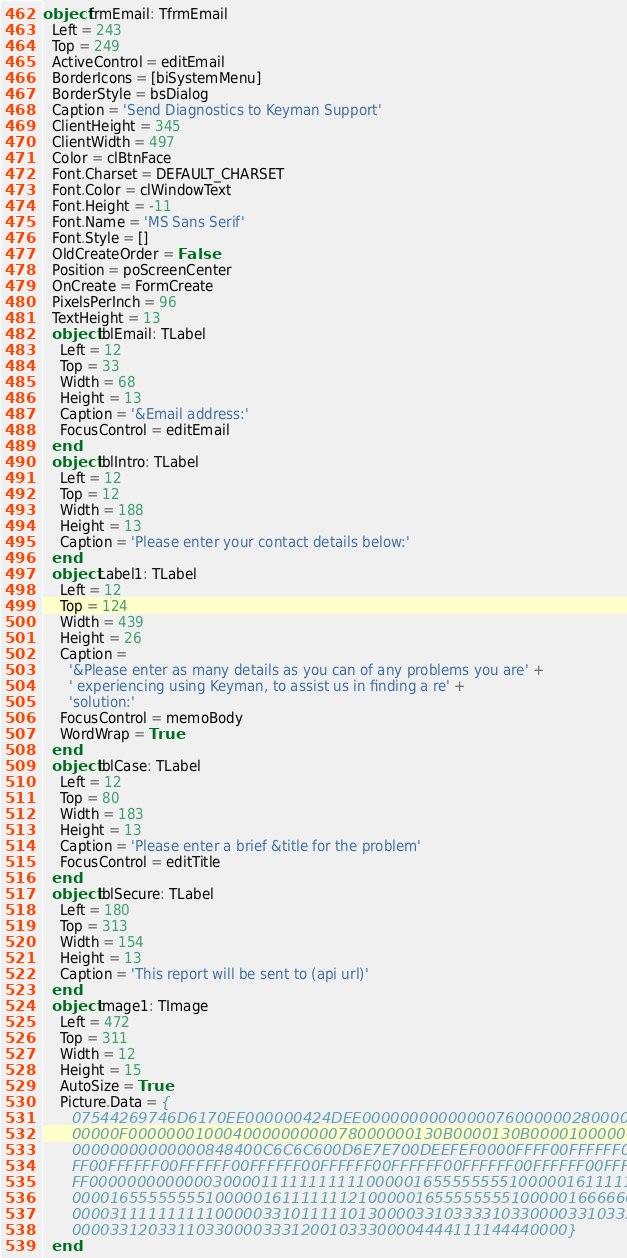Convert code to text. <code><loc_0><loc_0><loc_500><loc_500><_Pascal_>object frmEmail: TfrmEmail
  Left = 243
  Top = 249
  ActiveControl = editEmail
  BorderIcons = [biSystemMenu]
  BorderStyle = bsDialog
  Caption = 'Send Diagnostics to Keyman Support'
  ClientHeight = 345
  ClientWidth = 497
  Color = clBtnFace
  Font.Charset = DEFAULT_CHARSET
  Font.Color = clWindowText
  Font.Height = -11
  Font.Name = 'MS Sans Serif'
  Font.Style = []
  OldCreateOrder = False
  Position = poScreenCenter
  OnCreate = FormCreate
  PixelsPerInch = 96
  TextHeight = 13
  object lblEmail: TLabel
    Left = 12
    Top = 33
    Width = 68
    Height = 13
    Caption = '&Email address:'
    FocusControl = editEmail
  end
  object lblIntro: TLabel
    Left = 12
    Top = 12
    Width = 188
    Height = 13
    Caption = 'Please enter your contact details below:'
  end
  object Label1: TLabel
    Left = 12
    Top = 124
    Width = 439
    Height = 26
    Caption =
      '&Please enter as many details as you can of any problems you are' +
      ' experiencing using Keyman, to assist us in finding a re' +
      'solution:'
    FocusControl = memoBody
    WordWrap = True
  end
  object lblCase: TLabel
    Left = 12
    Top = 80
    Width = 183
    Height = 13
    Caption = 'Please enter a brief &title for the problem'
    FocusControl = editTitle
  end
  object lblSecure: TLabel
    Left = 180
    Top = 313
    Width = 154
    Height = 13
    Caption = 'This report will be sent to (api url)'
  end
  object Image1: TImage
    Left = 472
    Top = 311
    Width = 12
    Height = 15
    AutoSize = True
    Picture.Data = {
      07544269746D6170EE000000424DEE0000000000000076000000280000000C00
      00000F000000010004000000000078000000130B0000130B0000100000001000
      00000000000000848400C6C6C600D6E7E700DEEFEF0000FFFF00FFFFFF00FFFF
      FF00FFFFFF00FFFFFF00FFFFFF00FFFFFF00FFFFFF00FFFFFF00FFFFFF00FFFF
      FF00000000000003000011111111111000001655555555100000161111111210
      0000165555555510000016111111121000001655555555100000166666666610
      0000311111111110000033101111101300003310333310330000331033331033
      0000331203311033000033312001033300004444111144440000}
  end</code> 